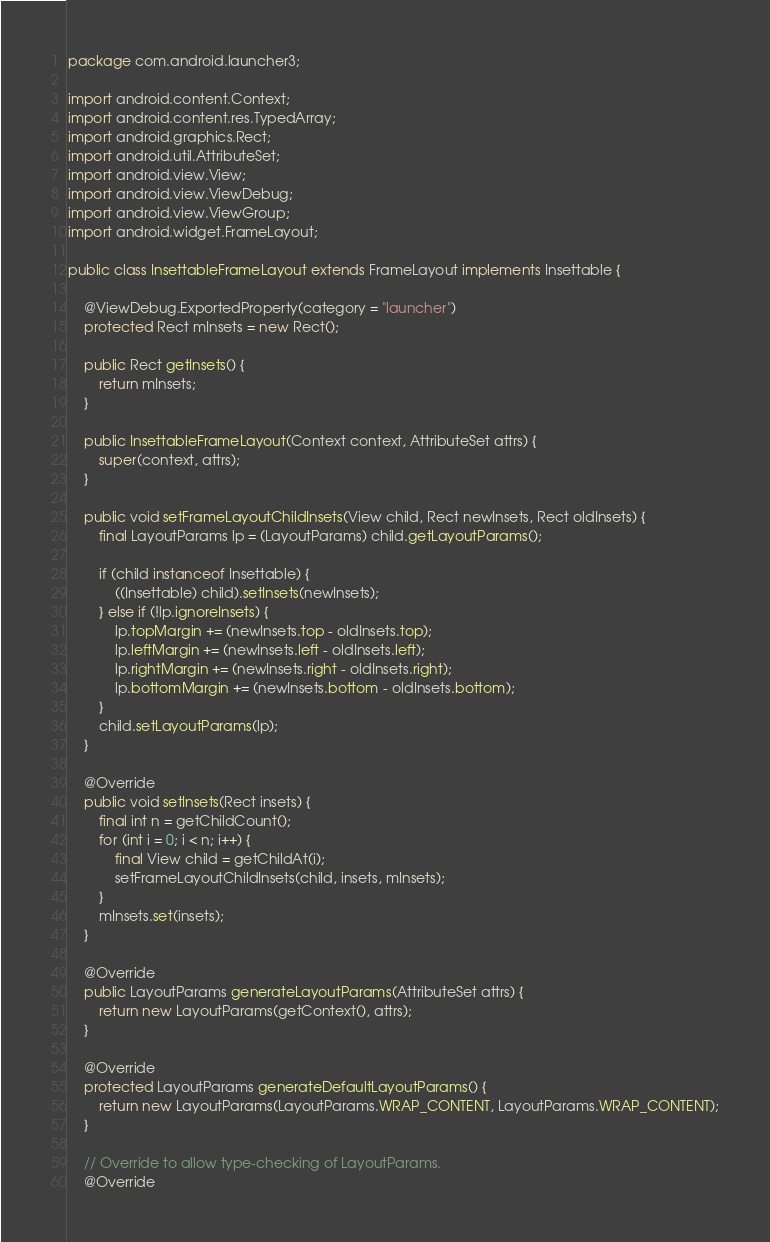<code> <loc_0><loc_0><loc_500><loc_500><_Java_>package com.android.launcher3;

import android.content.Context;
import android.content.res.TypedArray;
import android.graphics.Rect;
import android.util.AttributeSet;
import android.view.View;
import android.view.ViewDebug;
import android.view.ViewGroup;
import android.widget.FrameLayout;

public class InsettableFrameLayout extends FrameLayout implements Insettable {

    @ViewDebug.ExportedProperty(category = "launcher")
    protected Rect mInsets = new Rect();

    public Rect getInsets() {
        return mInsets;
    }

    public InsettableFrameLayout(Context context, AttributeSet attrs) {
        super(context, attrs);
    }

    public void setFrameLayoutChildInsets(View child, Rect newInsets, Rect oldInsets) {
        final LayoutParams lp = (LayoutParams) child.getLayoutParams();

        if (child instanceof Insettable) {
            ((Insettable) child).setInsets(newInsets);
        } else if (!lp.ignoreInsets) {
            lp.topMargin += (newInsets.top - oldInsets.top);
            lp.leftMargin += (newInsets.left - oldInsets.left);
            lp.rightMargin += (newInsets.right - oldInsets.right);
            lp.bottomMargin += (newInsets.bottom - oldInsets.bottom);
        }
        child.setLayoutParams(lp);
    }

    @Override
    public void setInsets(Rect insets) {
        final int n = getChildCount();
        for (int i = 0; i < n; i++) {
            final View child = getChildAt(i);
            setFrameLayoutChildInsets(child, insets, mInsets);
        }
        mInsets.set(insets);
    }

    @Override
    public LayoutParams generateLayoutParams(AttributeSet attrs) {
        return new LayoutParams(getContext(), attrs);
    }

    @Override
    protected LayoutParams generateDefaultLayoutParams() {
        return new LayoutParams(LayoutParams.WRAP_CONTENT, LayoutParams.WRAP_CONTENT);
    }

    // Override to allow type-checking of LayoutParams.
    @Override</code> 